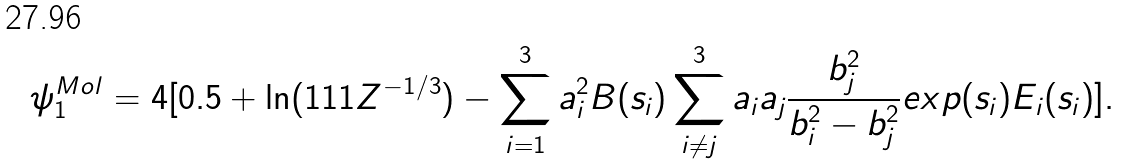Convert formula to latex. <formula><loc_0><loc_0><loc_500><loc_500>\psi ^ { M o l } _ { 1 } = 4 [ 0 . 5 + \ln ( 1 1 1 Z ^ { - 1 / 3 } ) - \sum _ { i = 1 } ^ { 3 } a ^ { 2 } _ { i } B ( s _ { i } ) \sum _ { i \ne j } ^ { 3 } a _ { i } a _ { j } \frac { b ^ { 2 } _ { j } } { b ^ { 2 } _ { i } - b ^ { 2 } _ { j } } e x p ( s _ { i } ) E _ { i } ( s _ { i } ) ] .</formula> 